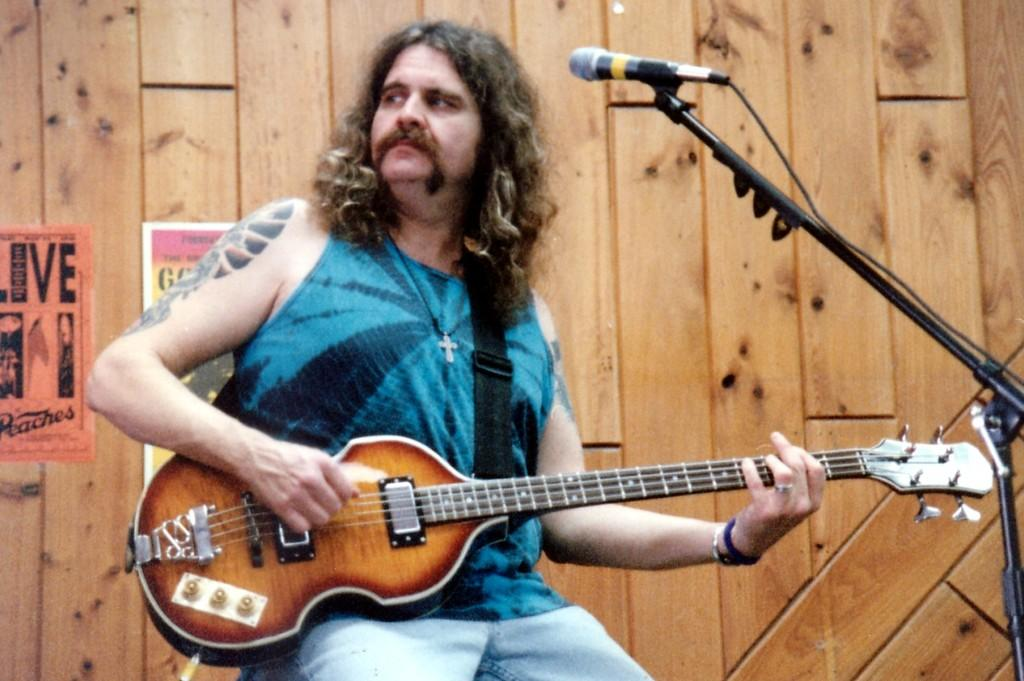What is the man in the image doing? The man is playing a guitar. What is the man wearing in the image? The man is wearing a blue t-shirt. How many boys are playing with the crow and egg in the image? There are no boys, crows, or eggs present in the image. The image only features a man playing a guitar while wearing a blue t-shirt. 